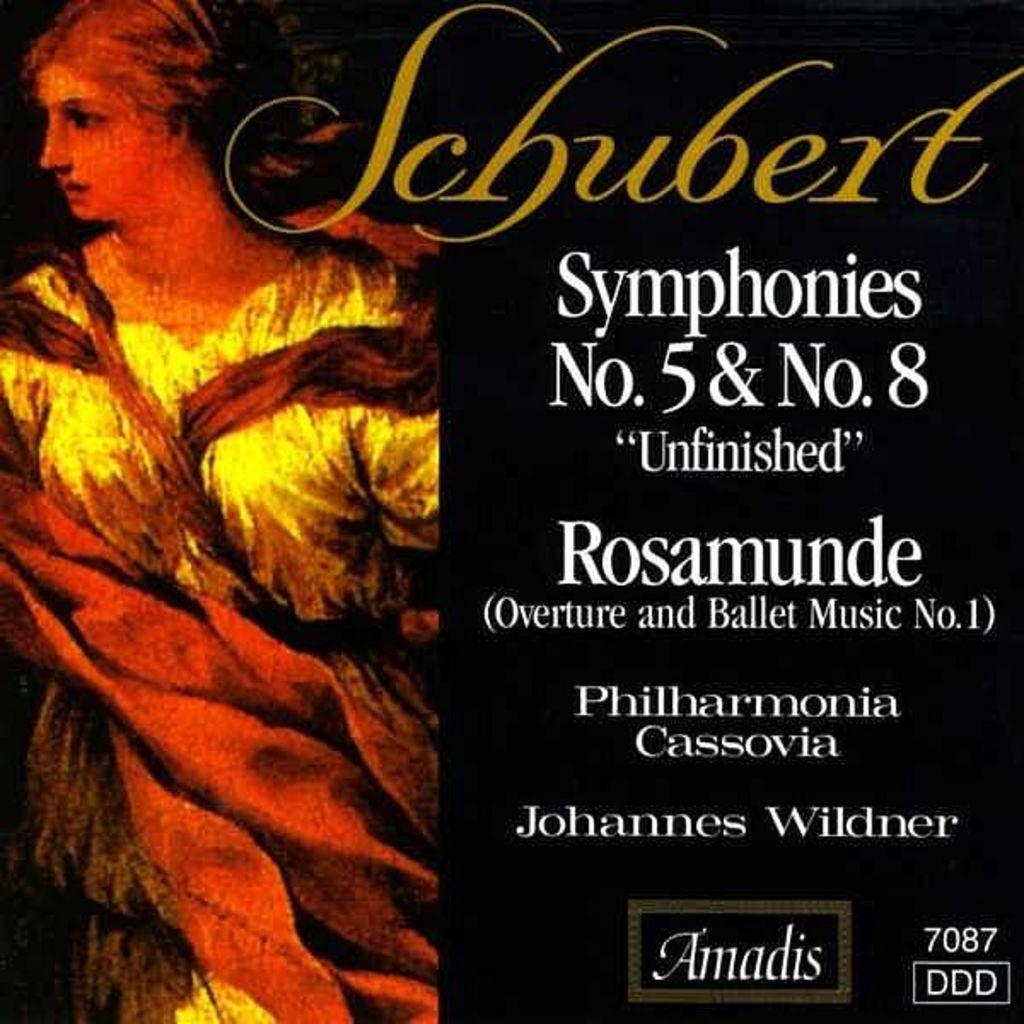What four numbers are on the album in the lower right hand corner?
Your answer should be very brief. 7087. 